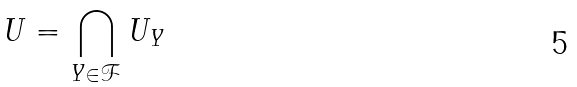<formula> <loc_0><loc_0><loc_500><loc_500>U = \bigcap _ { Y \in \mathcal { F } } U _ { Y }</formula> 